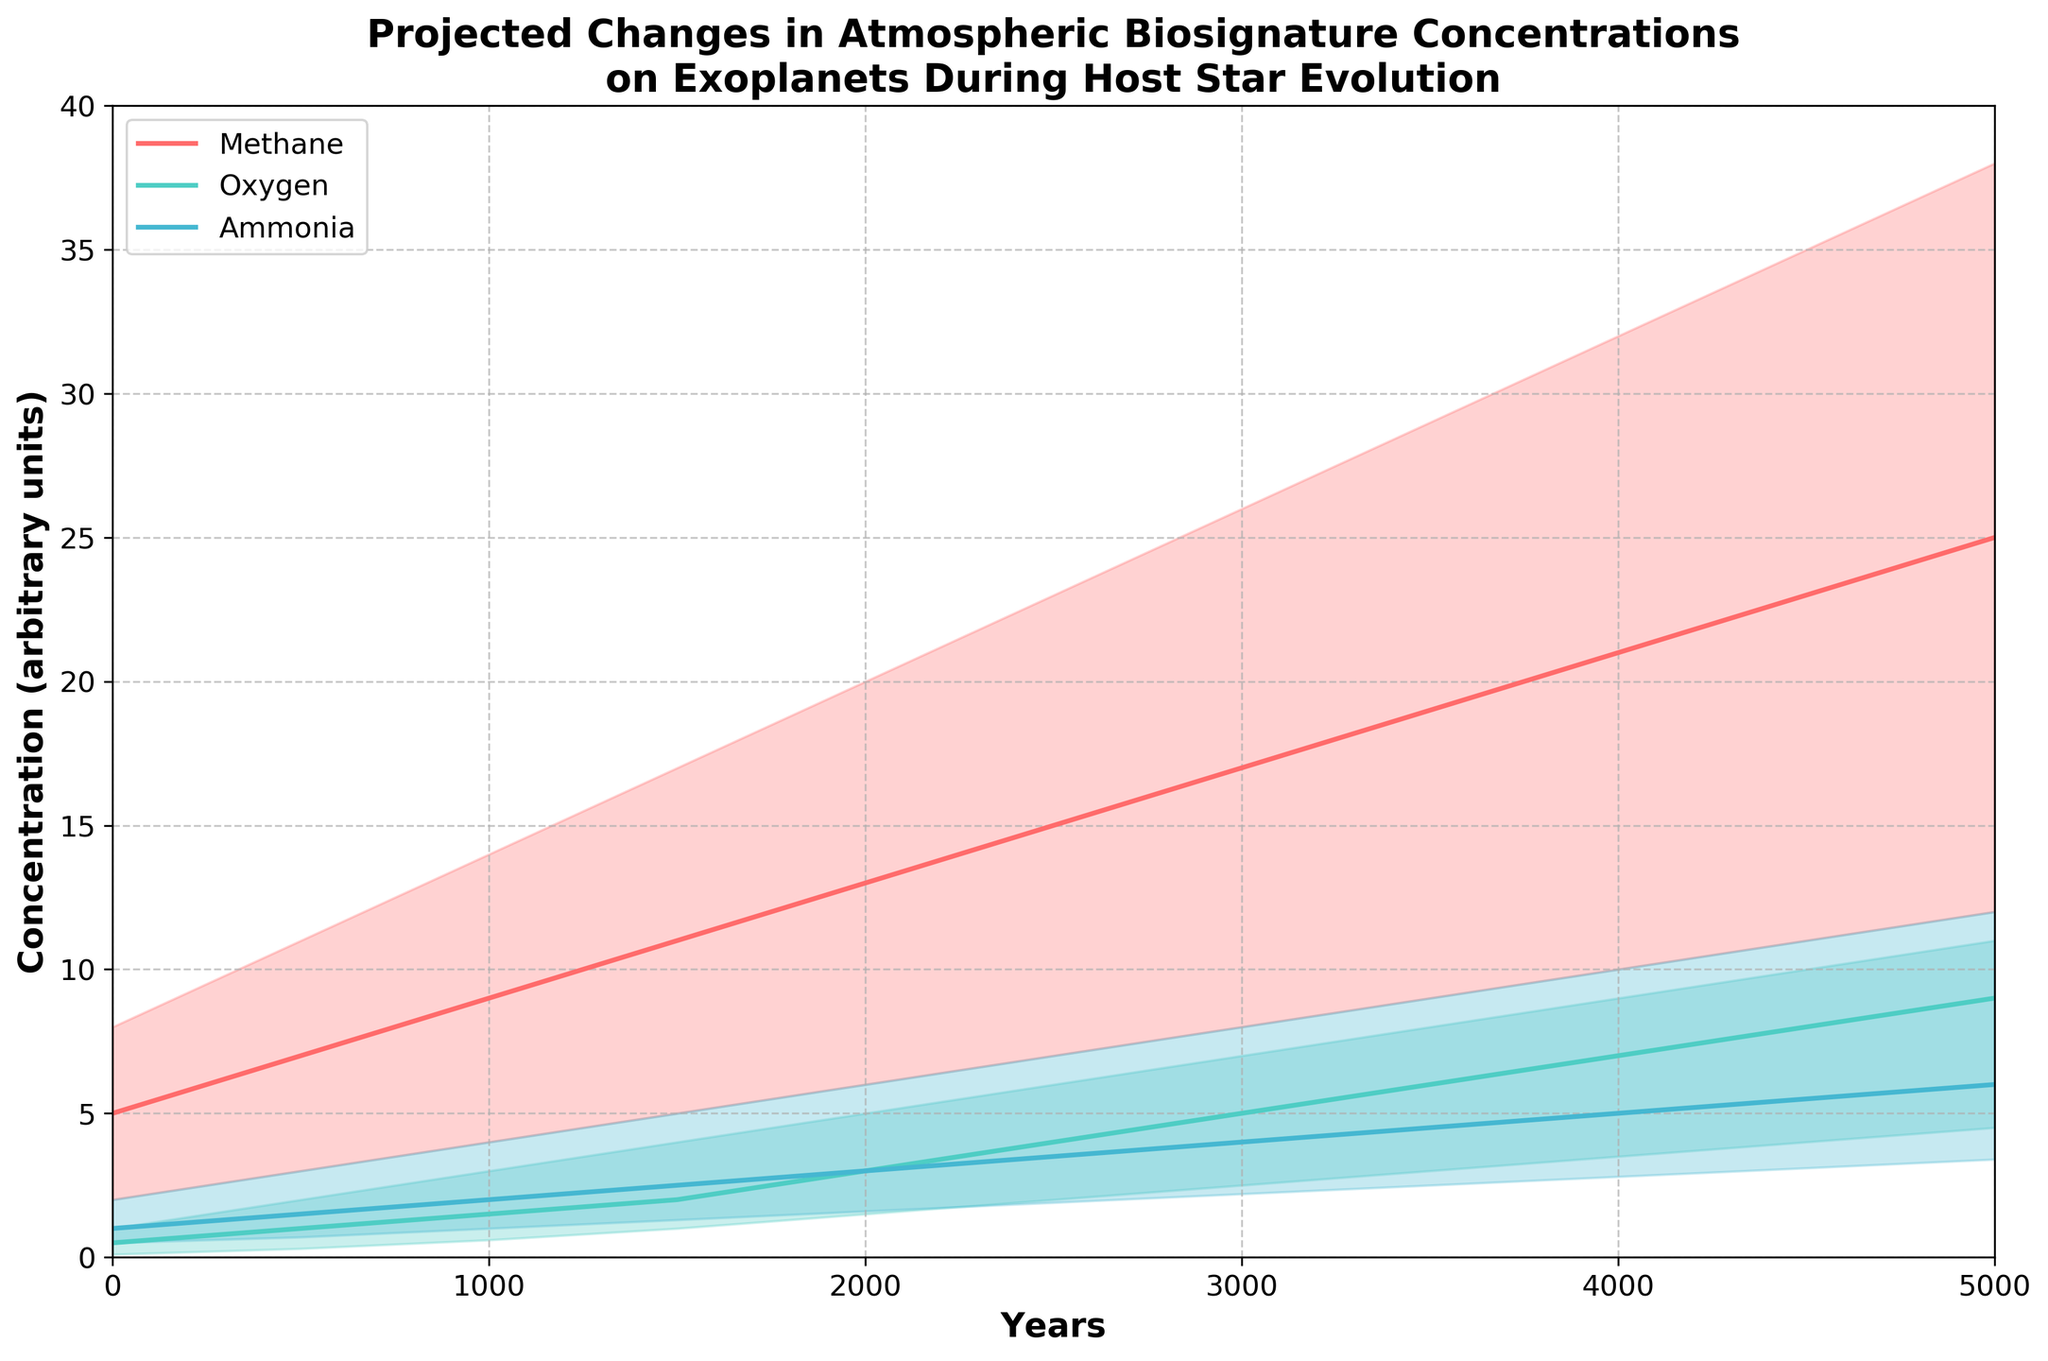What is the title of the figure? The title of the figure is located at the top and provides a concise summary of what the figure is about. By reading it, one can understand that the figure depicts the projected changes in atmospheric biosignature concentrations on exoplanets during their host star's main sequence evolution.
Answer: Projected Changes in Atmospheric Biosignature Concentrations on Exoplanets During Host Star Evolution What are the labels of the X and Y axes? The X-axis label indicates the independent variable, which is 'Years,' and the Y-axis label shows the dependent variable, 'Concentration (arbitrary units).' These labels help understand what is being plotted on each axis.
Answer: Years and Concentration (arbitrary units) Which gas shows the highest concentration at the 5000-year mark in the medium scenario? By inspecting the medium concentration lines on the graph at the 5000-year mark, one can compare the concentrations. Methane has the label closest to 5000 on the Y-axis, showing that it has the highest concentration.
Answer: Methane Between which years does the concentration of Oxygen in the medium scenario increase from 2 to 8 units? By examining the Oxygen-Medium line on the graph, we observe that the concentration increases from 2 units at around 1500 years to 8 units at around 4500 years.
Answer: 1500 to 4500 years How does the concentration of Ammonia in the medium scenario change from year 0 to 5000? Observing the Ammonia-Medium line on the graph, the concentration starts at 1 unit at year 0 and increases to 6 units by year 5000.
Answer: Increases from 1 to 6 units What is the range of concentration values for Methane at the 3000-year mark? At the 3000-year mark, find the lower and upper bounds of the shaded area for Methane. The lower bound is 8 units, and the upper bound is 26 units.
Answer: 8 to 26 units Compare the increase rates of Oxygen and Methane in the medium scenario from year 0 to 2500. Which one increases more steeply? Looking at the slopes of Oxygen-Medium and Methane-Medium lines from year 0 to 2500, Methane increases from 5 to 15 units, while Oxygen increases from 0.5 to 4 units. The rate of increase for Methane is steeper.
Answer: Methane What is the difference in high-concentration values between Oxygen and Ammonia at the 4000-year mark? Examine the high-concentration points at 4000 years. Oxygen is at 9 units, and Ammonia is at 10 units. The difference is 10 - 9.
Answer: 1 unit At which year does Methane in the low scenario reach a concentration of 9 units? To find when Methane-Low reaches 9 units, check the corresponding Y value on the Methane-Low curve. It is at the 3500-year mark.
Answer: 3500 years What is the trend of biosignature concentration levels for all gases as the year progresses? Observing the trend lines and fill areas for all gases, their concentrations generally increase over time during the host star's main sequence evolution. This trend can be noted for low, medium, and high scenarios alike.
Answer: Increase over time 